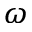Convert formula to latex. <formula><loc_0><loc_0><loc_500><loc_500>\omega</formula> 